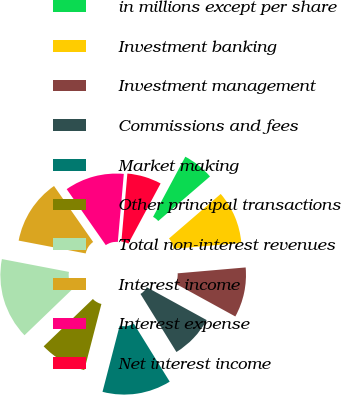Convert chart to OTSL. <chart><loc_0><loc_0><loc_500><loc_500><pie_chart><fcel>in millions except per share<fcel>Investment banking<fcel>Investment management<fcel>Commissions and fees<fcel>Market making<fcel>Other principal transactions<fcel>Total non-interest revenues<fcel>Interest income<fcel>Interest expense<fcel>Net interest income<nl><fcel>5.85%<fcel>9.94%<fcel>9.36%<fcel>8.19%<fcel>12.86%<fcel>8.77%<fcel>15.2%<fcel>12.28%<fcel>11.11%<fcel>6.43%<nl></chart> 